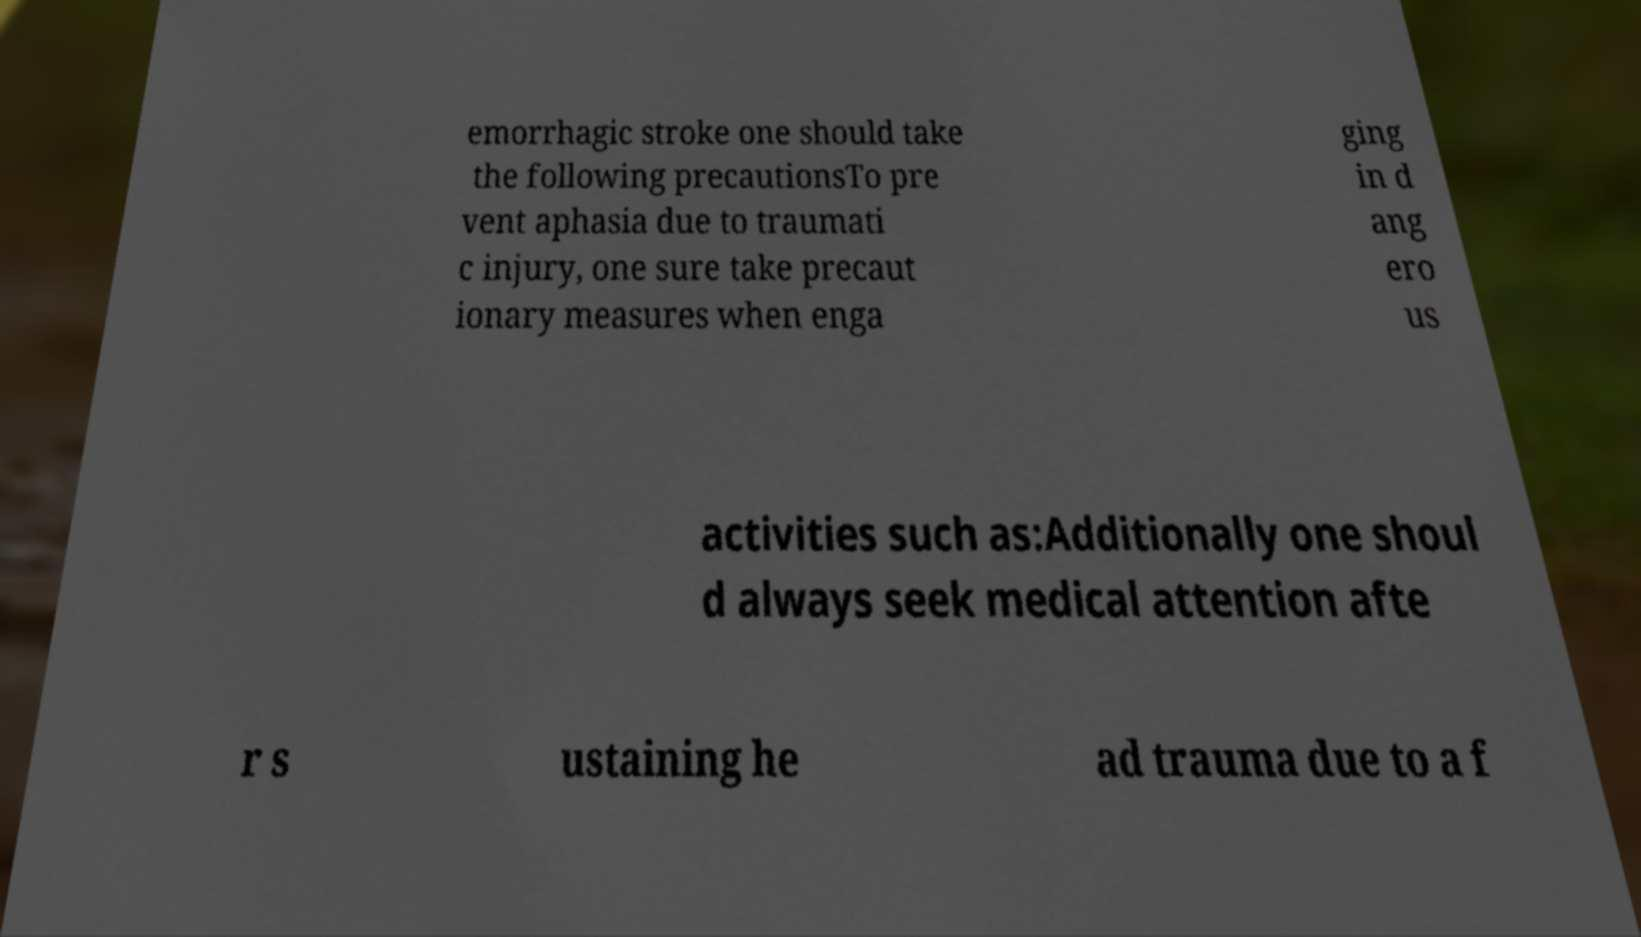Can you read and provide the text displayed in the image?This photo seems to have some interesting text. Can you extract and type it out for me? emorrhagic stroke one should take the following precautionsTo pre vent aphasia due to traumati c injury, one sure take precaut ionary measures when enga ging in d ang ero us activities such as:Additionally one shoul d always seek medical attention afte r s ustaining he ad trauma due to a f 